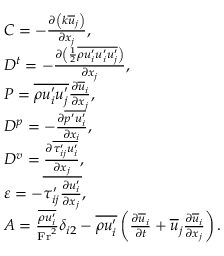Convert formula to latex. <formula><loc_0><loc_0><loc_500><loc_500>\begin{array} { r l } & { C = - \frac { \partial \left ( k \overline { u } _ { j } \right ) } { \partial x _ { j } } , } \\ & { D ^ { t } = - \frac { \partial \left ( \frac { 1 } { 2 } \overline { { \rho u _ { i } ^ { \prime } u _ { i } ^ { \prime } u _ { j } ^ { \prime } } } \right ) } { \partial x _ { j } } , } \\ & { P = \overline { { \rho u _ { i } ^ { \prime } u _ { j } ^ { \prime } } } \frac { \partial \overline { u } _ { i } } { \partial x _ { j } } , } \\ & { D ^ { p } = - \frac { \partial \overline { { p ^ { \prime } u _ { i } ^ { \prime } } } } { \partial x _ { i } } , } \\ & { D ^ { v } = \frac { \partial \overline { { \tau _ { i j } ^ { \prime } u _ { i } ^ { \prime } } } } { \partial x _ { j } } , } \\ & { \varepsilon = - \overline { { \tau _ { i j } ^ { \prime } \frac { \partial u _ { i } ^ { \prime } } { \partial x _ { j } } } } , } \\ & { A = \frac { \overline { { \rho u _ { i } ^ { \prime } } } } { F r ^ { 2 } } \delta _ { i 2 } - \overline { { \rho u _ { i } ^ { \prime } } } \left ( \frac { \partial \overline { u } _ { i } } { \partial t } + \overline { u } _ { j } \frac { \partial \overline { u } _ { i } } { \partial x _ { j } } \right ) . } \end{array}</formula> 